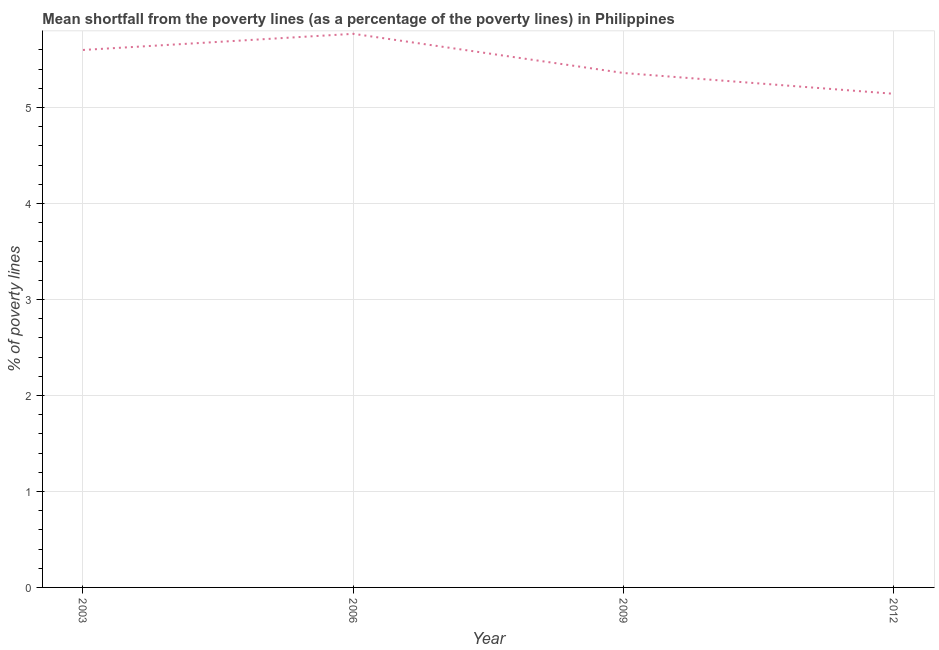What is the poverty gap at national poverty lines in 2006?
Ensure brevity in your answer.  5.77. Across all years, what is the maximum poverty gap at national poverty lines?
Give a very brief answer. 5.77. Across all years, what is the minimum poverty gap at national poverty lines?
Offer a terse response. 5.14. In which year was the poverty gap at national poverty lines maximum?
Provide a succinct answer. 2006. In which year was the poverty gap at national poverty lines minimum?
Offer a terse response. 2012. What is the sum of the poverty gap at national poverty lines?
Offer a terse response. 21.87. What is the difference between the poverty gap at national poverty lines in 2003 and 2009?
Your response must be concise. 0.24. What is the average poverty gap at national poverty lines per year?
Your answer should be compact. 5.47. What is the median poverty gap at national poverty lines?
Provide a succinct answer. 5.48. In how many years, is the poverty gap at national poverty lines greater than 5.2 %?
Give a very brief answer. 3. Do a majority of the years between 2006 and 2012 (inclusive) have poverty gap at national poverty lines greater than 3.4 %?
Make the answer very short. Yes. What is the ratio of the poverty gap at national poverty lines in 2006 to that in 2012?
Ensure brevity in your answer.  1.12. What is the difference between the highest and the second highest poverty gap at national poverty lines?
Provide a short and direct response. 0.17. What is the difference between the highest and the lowest poverty gap at national poverty lines?
Offer a very short reply. 0.62. Does the poverty gap at national poverty lines monotonically increase over the years?
Make the answer very short. No. How many years are there in the graph?
Give a very brief answer. 4. What is the difference between two consecutive major ticks on the Y-axis?
Offer a very short reply. 1. What is the title of the graph?
Provide a short and direct response. Mean shortfall from the poverty lines (as a percentage of the poverty lines) in Philippines. What is the label or title of the Y-axis?
Keep it short and to the point. % of poverty lines. What is the % of poverty lines of 2006?
Give a very brief answer. 5.77. What is the % of poverty lines of 2009?
Offer a very short reply. 5.36. What is the % of poverty lines in 2012?
Your response must be concise. 5.14. What is the difference between the % of poverty lines in 2003 and 2006?
Provide a short and direct response. -0.17. What is the difference between the % of poverty lines in 2003 and 2009?
Make the answer very short. 0.24. What is the difference between the % of poverty lines in 2003 and 2012?
Your answer should be compact. 0.46. What is the difference between the % of poverty lines in 2006 and 2009?
Your answer should be compact. 0.41. What is the difference between the % of poverty lines in 2006 and 2012?
Your answer should be very brief. 0.62. What is the difference between the % of poverty lines in 2009 and 2012?
Provide a short and direct response. 0.22. What is the ratio of the % of poverty lines in 2003 to that in 2009?
Provide a short and direct response. 1.04. What is the ratio of the % of poverty lines in 2003 to that in 2012?
Your response must be concise. 1.09. What is the ratio of the % of poverty lines in 2006 to that in 2009?
Offer a terse response. 1.08. What is the ratio of the % of poverty lines in 2006 to that in 2012?
Your answer should be compact. 1.12. What is the ratio of the % of poverty lines in 2009 to that in 2012?
Your answer should be compact. 1.04. 